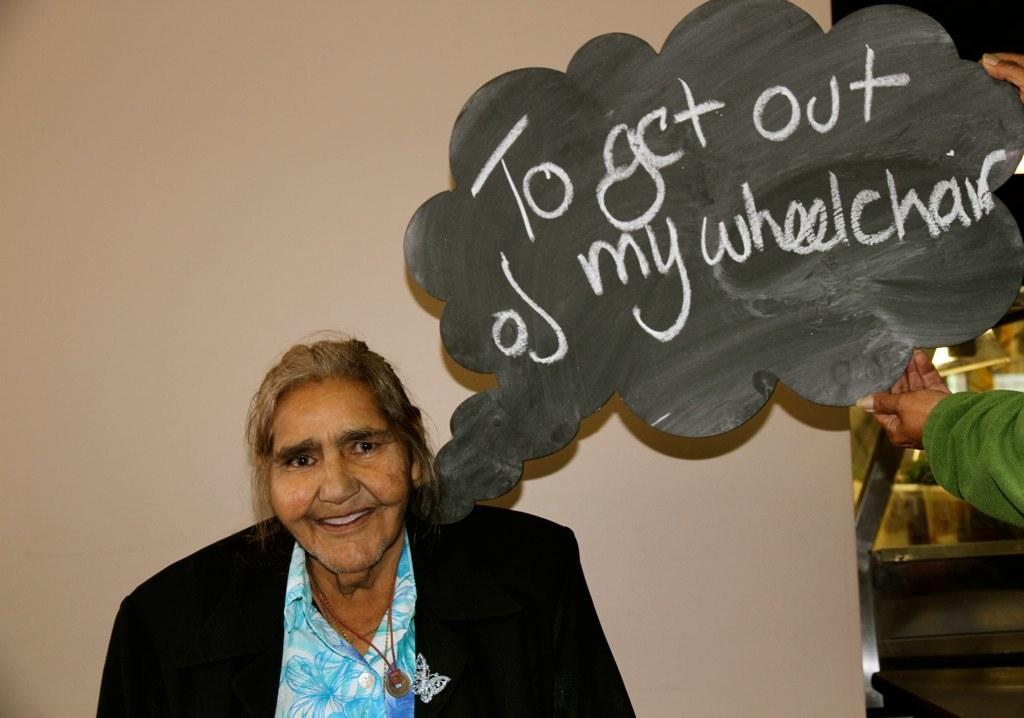How many people are in the image? There are two persons in the image. Can you describe one of the persons in the image? One of the persons is a woman. What is the woman wearing in the image? The woman is wearing a coat. What is one of the persons holding in the image? One person is holding a board with text on it. What type of glove is the woman wearing in the image? The woman is not wearing a glove in the image; she is wearing a coat. What question is being asked on the board held by one of the persons? There is no question visible on the board held by one of the persons in the image. 